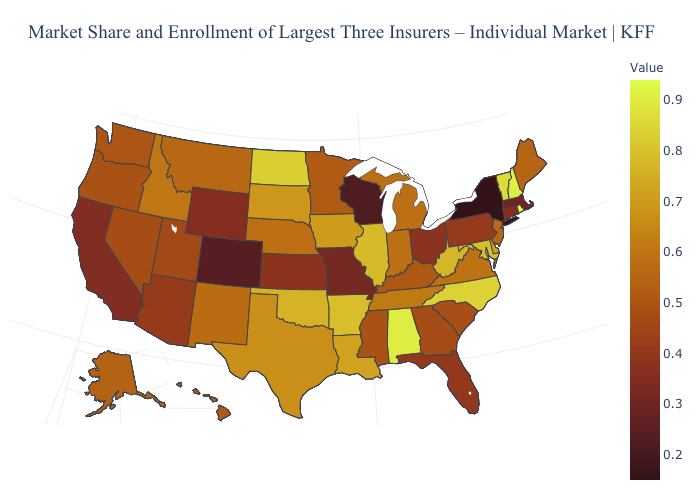Among the states that border North Dakota , does Minnesota have the highest value?
Concise answer only. No. Among the states that border Wisconsin , does Illinois have the lowest value?
Be succinct. No. Among the states that border South Dakota , which have the lowest value?
Give a very brief answer. Wyoming. Does Florida have the lowest value in the South?
Keep it brief. Yes. Does Alaska have the lowest value in the West?
Write a very short answer. No. Which states have the lowest value in the USA?
Answer briefly. New York. Which states have the highest value in the USA?
Quick response, please. Rhode Island. Among the states that border Maine , which have the highest value?
Answer briefly. New Hampshire. Which states have the highest value in the USA?
Answer briefly. Rhode Island. 